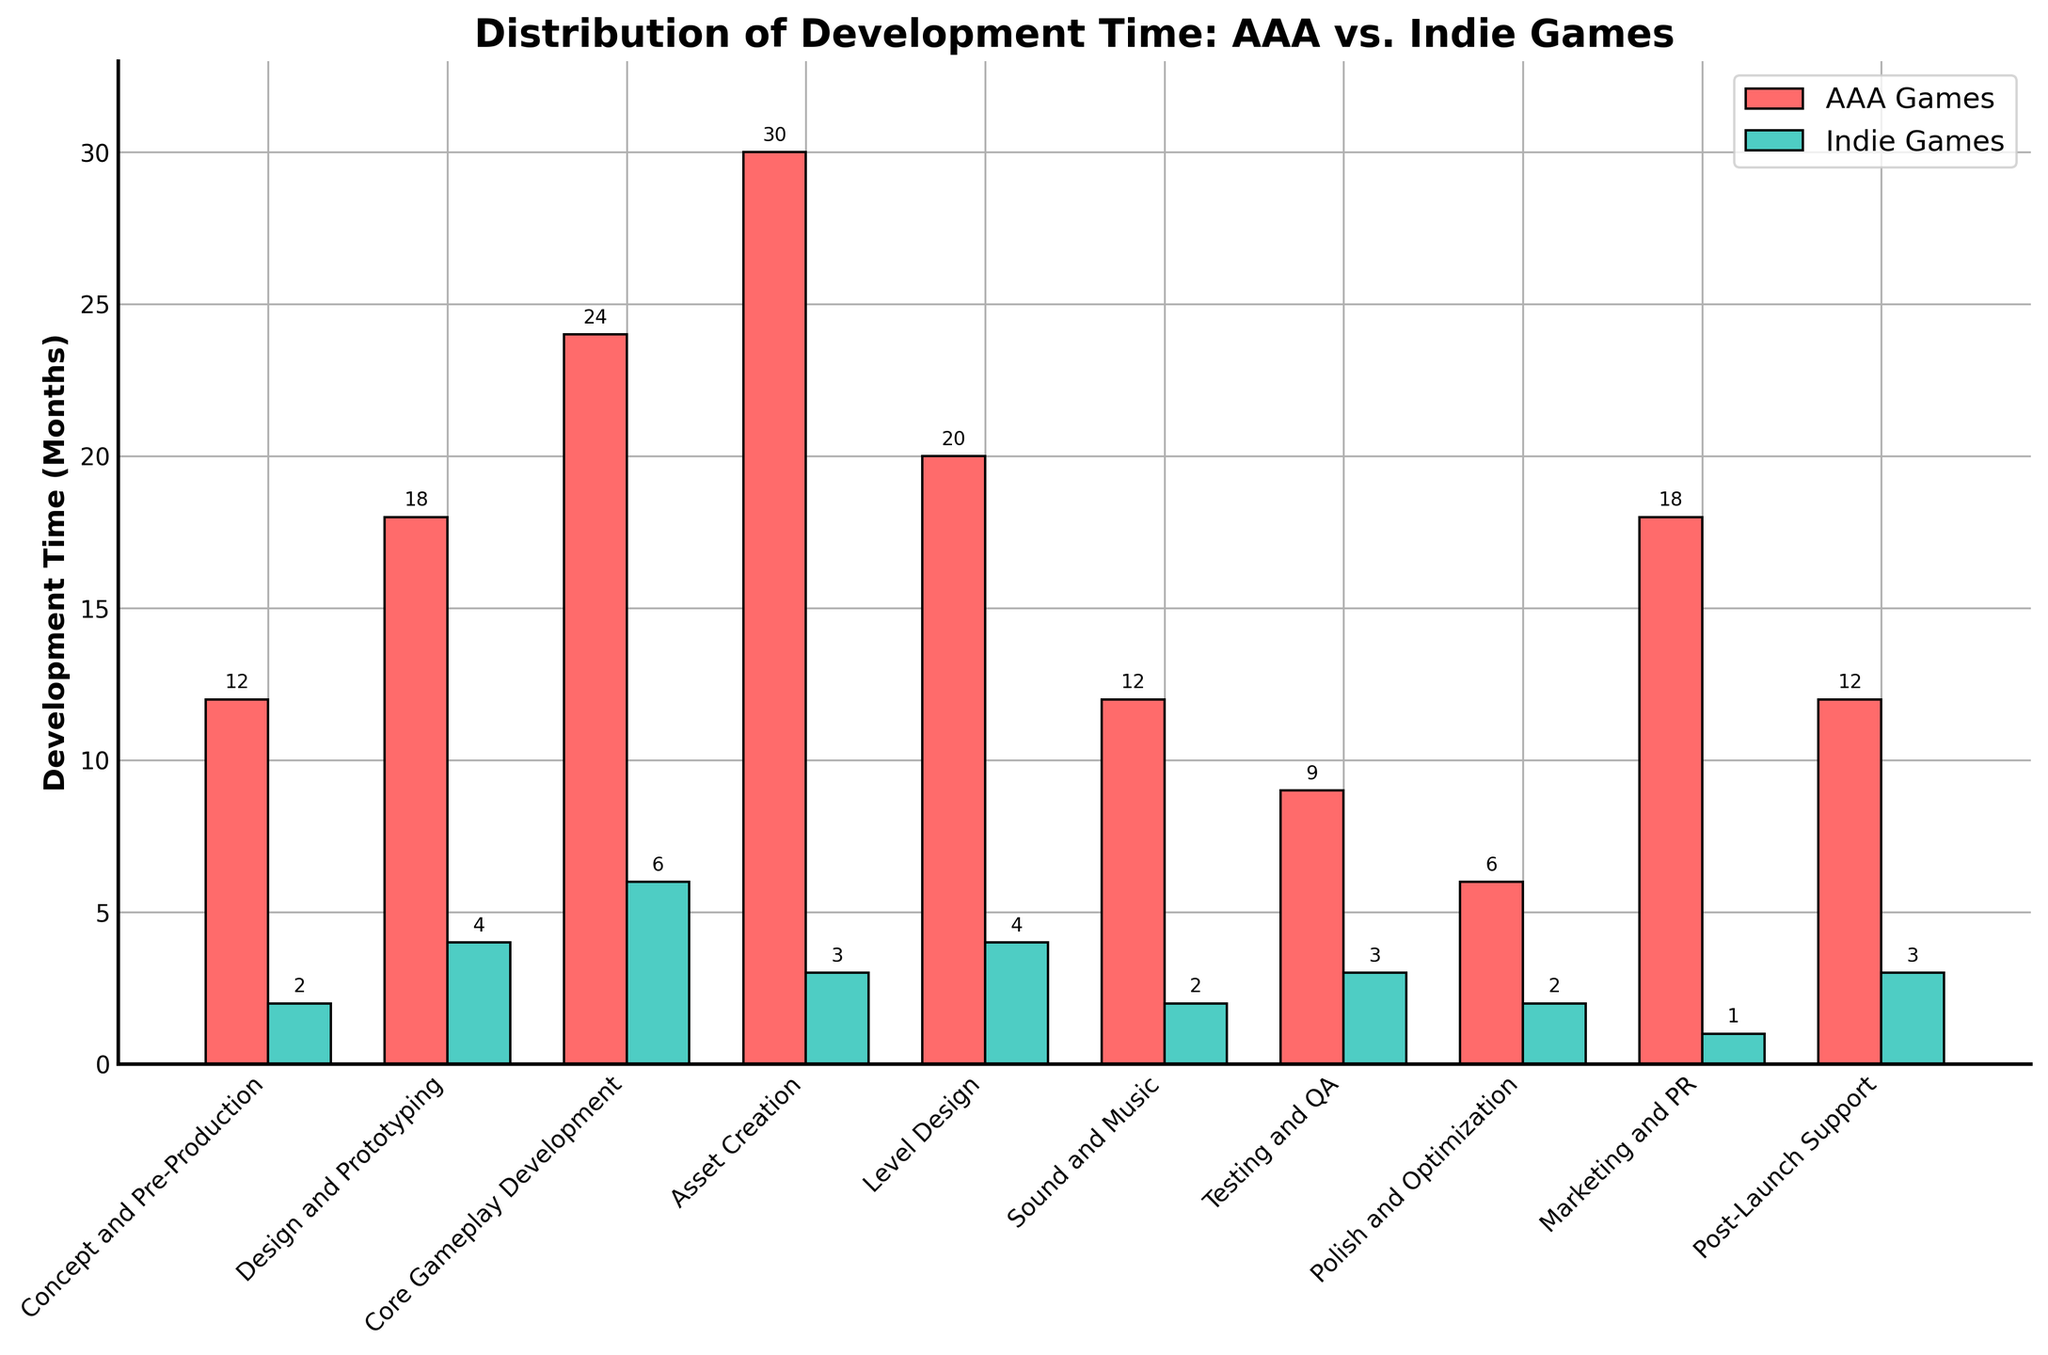What's the total development time for AAA games across all stages? To find the total development time for AAA games, sum the development times in all stages: 12 + 18 + 24 + 30 + 20 + 12 + 9 + 6 + 18 + 12 = 161 months.
Answer: 161 months How does the development time for 'Core Gameplay Development' compare between AAA and indie games? For 'Core Gameplay Development', AAA games take 24 months, while indie games take 6 months. Therefore, AAA games take 24 - 6 = 18 months longer.
Answer: 18 months longer Which game type allocates more time for 'Asset Creation', and by how much? For 'Asset Creation', AAA games allocate 30 months and indie games allocate 3 months. Thus, AAA games allocate 30 - 3 = 27 months more.
Answer: 27 months more What's the average development time for each stage in indie games? To find the average, sum the development times for all stages and divide by the number of stages. The sum is 2 + 4 + 6 + 3 + 4 + 2 + 3 + 2 + 1 + 3 = 30 months. There are 10 stages, so the average is 30 / 10 = 3 months.
Answer: 3 months How long do indie games spend on 'Marketing and PR' relative to AAA games? Indie games spend 1 month on 'Marketing and PR' compared to AAA games, which spend 18 months. Therefore, indie games spend 1 / 18 = 1/18 or approximately 5.56% of the time AAA games spend.
Answer: 1/18 or 5.56% What is the ratio of time spent on 'Testing and QA' between AAA and indie games? AAA games spend 9 months on 'Testing and QA', while indie games spend 3 months. The ratio is 9 / 3 = 3:1.
Answer: 3:1 